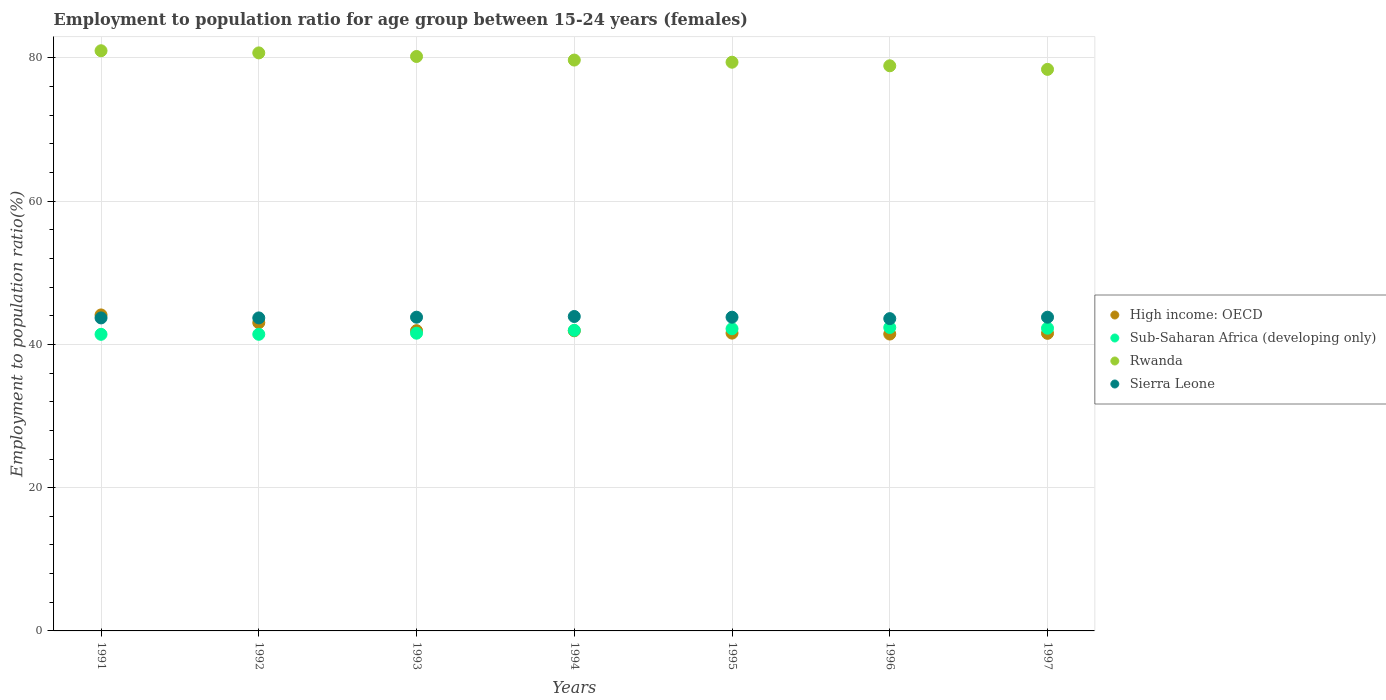Is the number of dotlines equal to the number of legend labels?
Provide a succinct answer. Yes. What is the employment to population ratio in Sub-Saharan Africa (developing only) in 1995?
Your response must be concise. 42.19. Across all years, what is the maximum employment to population ratio in Sierra Leone?
Offer a very short reply. 43.9. Across all years, what is the minimum employment to population ratio in Sierra Leone?
Your answer should be compact. 43.6. In which year was the employment to population ratio in Sub-Saharan Africa (developing only) maximum?
Your response must be concise. 1996. In which year was the employment to population ratio in Sierra Leone minimum?
Ensure brevity in your answer.  1996. What is the total employment to population ratio in High income: OECD in the graph?
Ensure brevity in your answer.  295.55. What is the difference between the employment to population ratio in High income: OECD in 1994 and that in 1996?
Offer a terse response. 0.45. What is the difference between the employment to population ratio in Sub-Saharan Africa (developing only) in 1991 and the employment to population ratio in Rwanda in 1992?
Keep it short and to the point. -39.29. What is the average employment to population ratio in Sierra Leone per year?
Ensure brevity in your answer.  43.76. In the year 1997, what is the difference between the employment to population ratio in Rwanda and employment to population ratio in Sub-Saharan Africa (developing only)?
Keep it short and to the point. 36.14. In how many years, is the employment to population ratio in Sierra Leone greater than 36 %?
Make the answer very short. 7. What is the ratio of the employment to population ratio in Sierra Leone in 1991 to that in 1995?
Your answer should be very brief. 1. Is the employment to population ratio in Sierra Leone in 1993 less than that in 1995?
Your answer should be very brief. No. Is the difference between the employment to population ratio in Rwanda in 1991 and 1997 greater than the difference between the employment to population ratio in Sub-Saharan Africa (developing only) in 1991 and 1997?
Provide a succinct answer. Yes. What is the difference between the highest and the second highest employment to population ratio in Rwanda?
Offer a terse response. 0.3. What is the difference between the highest and the lowest employment to population ratio in Sub-Saharan Africa (developing only)?
Your response must be concise. 0.95. Is the sum of the employment to population ratio in High income: OECD in 1991 and 1993 greater than the maximum employment to population ratio in Sierra Leone across all years?
Your answer should be compact. Yes. Is it the case that in every year, the sum of the employment to population ratio in Sierra Leone and employment to population ratio in High income: OECD  is greater than the employment to population ratio in Rwanda?
Your answer should be very brief. Yes. Is the employment to population ratio in Sierra Leone strictly greater than the employment to population ratio in Rwanda over the years?
Provide a succinct answer. No. Is the employment to population ratio in High income: OECD strictly less than the employment to population ratio in Sub-Saharan Africa (developing only) over the years?
Provide a short and direct response. No. Does the graph contain any zero values?
Offer a terse response. No. Does the graph contain grids?
Offer a terse response. Yes. Where does the legend appear in the graph?
Give a very brief answer. Center right. How many legend labels are there?
Offer a terse response. 4. How are the legend labels stacked?
Keep it short and to the point. Vertical. What is the title of the graph?
Offer a very short reply. Employment to population ratio for age group between 15-24 years (females). What is the label or title of the Y-axis?
Your response must be concise. Employment to population ratio(%). What is the Employment to population ratio(%) in High income: OECD in 1991?
Your answer should be compact. 44.12. What is the Employment to population ratio(%) of Sub-Saharan Africa (developing only) in 1991?
Give a very brief answer. 41.41. What is the Employment to population ratio(%) in Rwanda in 1991?
Your answer should be compact. 81. What is the Employment to population ratio(%) in Sierra Leone in 1991?
Your answer should be compact. 43.7. What is the Employment to population ratio(%) of High income: OECD in 1992?
Ensure brevity in your answer.  43.03. What is the Employment to population ratio(%) in Sub-Saharan Africa (developing only) in 1992?
Make the answer very short. 41.41. What is the Employment to population ratio(%) of Rwanda in 1992?
Your answer should be compact. 80.7. What is the Employment to population ratio(%) in Sierra Leone in 1992?
Ensure brevity in your answer.  43.7. What is the Employment to population ratio(%) of High income: OECD in 1993?
Give a very brief answer. 41.92. What is the Employment to population ratio(%) of Sub-Saharan Africa (developing only) in 1993?
Make the answer very short. 41.57. What is the Employment to population ratio(%) of Rwanda in 1993?
Offer a very short reply. 80.2. What is the Employment to population ratio(%) in Sierra Leone in 1993?
Your answer should be compact. 43.8. What is the Employment to population ratio(%) of High income: OECD in 1994?
Your answer should be very brief. 41.9. What is the Employment to population ratio(%) of Sub-Saharan Africa (developing only) in 1994?
Your answer should be very brief. 41.97. What is the Employment to population ratio(%) of Rwanda in 1994?
Keep it short and to the point. 79.7. What is the Employment to population ratio(%) of Sierra Leone in 1994?
Offer a very short reply. 43.9. What is the Employment to population ratio(%) in High income: OECD in 1995?
Provide a short and direct response. 41.58. What is the Employment to population ratio(%) of Sub-Saharan Africa (developing only) in 1995?
Offer a terse response. 42.19. What is the Employment to population ratio(%) in Rwanda in 1995?
Keep it short and to the point. 79.4. What is the Employment to population ratio(%) in Sierra Leone in 1995?
Offer a terse response. 43.8. What is the Employment to population ratio(%) of High income: OECD in 1996?
Offer a very short reply. 41.45. What is the Employment to population ratio(%) of Sub-Saharan Africa (developing only) in 1996?
Ensure brevity in your answer.  42.36. What is the Employment to population ratio(%) in Rwanda in 1996?
Make the answer very short. 78.9. What is the Employment to population ratio(%) in Sierra Leone in 1996?
Your answer should be compact. 43.6. What is the Employment to population ratio(%) in High income: OECD in 1997?
Your answer should be compact. 41.55. What is the Employment to population ratio(%) of Sub-Saharan Africa (developing only) in 1997?
Offer a terse response. 42.26. What is the Employment to population ratio(%) in Rwanda in 1997?
Your response must be concise. 78.4. What is the Employment to population ratio(%) of Sierra Leone in 1997?
Provide a short and direct response. 43.8. Across all years, what is the maximum Employment to population ratio(%) of High income: OECD?
Provide a short and direct response. 44.12. Across all years, what is the maximum Employment to population ratio(%) in Sub-Saharan Africa (developing only)?
Your response must be concise. 42.36. Across all years, what is the maximum Employment to population ratio(%) of Rwanda?
Make the answer very short. 81. Across all years, what is the maximum Employment to population ratio(%) of Sierra Leone?
Provide a short and direct response. 43.9. Across all years, what is the minimum Employment to population ratio(%) in High income: OECD?
Your answer should be very brief. 41.45. Across all years, what is the minimum Employment to population ratio(%) in Sub-Saharan Africa (developing only)?
Offer a very short reply. 41.41. Across all years, what is the minimum Employment to population ratio(%) of Rwanda?
Your answer should be compact. 78.4. Across all years, what is the minimum Employment to population ratio(%) in Sierra Leone?
Provide a short and direct response. 43.6. What is the total Employment to population ratio(%) in High income: OECD in the graph?
Ensure brevity in your answer.  295.55. What is the total Employment to population ratio(%) in Sub-Saharan Africa (developing only) in the graph?
Your response must be concise. 293.17. What is the total Employment to population ratio(%) in Rwanda in the graph?
Make the answer very short. 558.3. What is the total Employment to population ratio(%) of Sierra Leone in the graph?
Offer a terse response. 306.3. What is the difference between the Employment to population ratio(%) of High income: OECD in 1991 and that in 1992?
Offer a very short reply. 1.08. What is the difference between the Employment to population ratio(%) in Sub-Saharan Africa (developing only) in 1991 and that in 1992?
Provide a succinct answer. -0. What is the difference between the Employment to population ratio(%) of High income: OECD in 1991 and that in 1993?
Your response must be concise. 2.2. What is the difference between the Employment to population ratio(%) in Sub-Saharan Africa (developing only) in 1991 and that in 1993?
Provide a short and direct response. -0.16. What is the difference between the Employment to population ratio(%) in High income: OECD in 1991 and that in 1994?
Ensure brevity in your answer.  2.21. What is the difference between the Employment to population ratio(%) of Sub-Saharan Africa (developing only) in 1991 and that in 1994?
Your answer should be very brief. -0.56. What is the difference between the Employment to population ratio(%) of Rwanda in 1991 and that in 1994?
Your response must be concise. 1.3. What is the difference between the Employment to population ratio(%) of High income: OECD in 1991 and that in 1995?
Give a very brief answer. 2.54. What is the difference between the Employment to population ratio(%) in Sub-Saharan Africa (developing only) in 1991 and that in 1995?
Offer a terse response. -0.78. What is the difference between the Employment to population ratio(%) of Rwanda in 1991 and that in 1995?
Provide a succinct answer. 1.6. What is the difference between the Employment to population ratio(%) in High income: OECD in 1991 and that in 1996?
Your answer should be very brief. 2.67. What is the difference between the Employment to population ratio(%) of Sub-Saharan Africa (developing only) in 1991 and that in 1996?
Ensure brevity in your answer.  -0.95. What is the difference between the Employment to population ratio(%) in Rwanda in 1991 and that in 1996?
Offer a terse response. 2.1. What is the difference between the Employment to population ratio(%) of Sierra Leone in 1991 and that in 1996?
Keep it short and to the point. 0.1. What is the difference between the Employment to population ratio(%) of High income: OECD in 1991 and that in 1997?
Offer a terse response. 2.57. What is the difference between the Employment to population ratio(%) in Sub-Saharan Africa (developing only) in 1991 and that in 1997?
Your answer should be very brief. -0.85. What is the difference between the Employment to population ratio(%) of Sierra Leone in 1991 and that in 1997?
Provide a short and direct response. -0.1. What is the difference between the Employment to population ratio(%) in High income: OECD in 1992 and that in 1993?
Give a very brief answer. 1.11. What is the difference between the Employment to population ratio(%) in Sub-Saharan Africa (developing only) in 1992 and that in 1993?
Offer a terse response. -0.16. What is the difference between the Employment to population ratio(%) in Sierra Leone in 1992 and that in 1993?
Your answer should be very brief. -0.1. What is the difference between the Employment to population ratio(%) of High income: OECD in 1992 and that in 1994?
Give a very brief answer. 1.13. What is the difference between the Employment to population ratio(%) in Sub-Saharan Africa (developing only) in 1992 and that in 1994?
Your answer should be very brief. -0.56. What is the difference between the Employment to population ratio(%) of Sierra Leone in 1992 and that in 1994?
Your response must be concise. -0.2. What is the difference between the Employment to population ratio(%) in High income: OECD in 1992 and that in 1995?
Offer a very short reply. 1.45. What is the difference between the Employment to population ratio(%) in Sub-Saharan Africa (developing only) in 1992 and that in 1995?
Keep it short and to the point. -0.77. What is the difference between the Employment to population ratio(%) in Rwanda in 1992 and that in 1995?
Give a very brief answer. 1.3. What is the difference between the Employment to population ratio(%) of Sierra Leone in 1992 and that in 1995?
Provide a short and direct response. -0.1. What is the difference between the Employment to population ratio(%) of High income: OECD in 1992 and that in 1996?
Your answer should be very brief. 1.58. What is the difference between the Employment to population ratio(%) of Sub-Saharan Africa (developing only) in 1992 and that in 1996?
Offer a terse response. -0.95. What is the difference between the Employment to population ratio(%) in Rwanda in 1992 and that in 1996?
Make the answer very short. 1.8. What is the difference between the Employment to population ratio(%) of Sierra Leone in 1992 and that in 1996?
Your answer should be very brief. 0.1. What is the difference between the Employment to population ratio(%) of High income: OECD in 1992 and that in 1997?
Your answer should be very brief. 1.49. What is the difference between the Employment to population ratio(%) in Sub-Saharan Africa (developing only) in 1992 and that in 1997?
Give a very brief answer. -0.85. What is the difference between the Employment to population ratio(%) in Sierra Leone in 1992 and that in 1997?
Your response must be concise. -0.1. What is the difference between the Employment to population ratio(%) in High income: OECD in 1993 and that in 1994?
Offer a terse response. 0.02. What is the difference between the Employment to population ratio(%) of Sub-Saharan Africa (developing only) in 1993 and that in 1994?
Give a very brief answer. -0.4. What is the difference between the Employment to population ratio(%) in High income: OECD in 1993 and that in 1995?
Ensure brevity in your answer.  0.34. What is the difference between the Employment to population ratio(%) of Sub-Saharan Africa (developing only) in 1993 and that in 1995?
Provide a short and direct response. -0.62. What is the difference between the Employment to population ratio(%) of Rwanda in 1993 and that in 1995?
Make the answer very short. 0.8. What is the difference between the Employment to population ratio(%) in Sierra Leone in 1993 and that in 1995?
Offer a very short reply. 0. What is the difference between the Employment to population ratio(%) of High income: OECD in 1993 and that in 1996?
Provide a short and direct response. 0.47. What is the difference between the Employment to population ratio(%) of Sub-Saharan Africa (developing only) in 1993 and that in 1996?
Your response must be concise. -0.79. What is the difference between the Employment to population ratio(%) in Rwanda in 1993 and that in 1996?
Your answer should be very brief. 1.3. What is the difference between the Employment to population ratio(%) of Sierra Leone in 1993 and that in 1996?
Ensure brevity in your answer.  0.2. What is the difference between the Employment to population ratio(%) in High income: OECD in 1993 and that in 1997?
Make the answer very short. 0.37. What is the difference between the Employment to population ratio(%) in Sub-Saharan Africa (developing only) in 1993 and that in 1997?
Your response must be concise. -0.69. What is the difference between the Employment to population ratio(%) of Rwanda in 1993 and that in 1997?
Make the answer very short. 1.8. What is the difference between the Employment to population ratio(%) of Sierra Leone in 1993 and that in 1997?
Your answer should be compact. 0. What is the difference between the Employment to population ratio(%) of High income: OECD in 1994 and that in 1995?
Keep it short and to the point. 0.32. What is the difference between the Employment to population ratio(%) in Sub-Saharan Africa (developing only) in 1994 and that in 1995?
Give a very brief answer. -0.22. What is the difference between the Employment to population ratio(%) in Rwanda in 1994 and that in 1995?
Provide a succinct answer. 0.3. What is the difference between the Employment to population ratio(%) in Sierra Leone in 1994 and that in 1995?
Give a very brief answer. 0.1. What is the difference between the Employment to population ratio(%) of High income: OECD in 1994 and that in 1996?
Your answer should be very brief. 0.45. What is the difference between the Employment to population ratio(%) in Sub-Saharan Africa (developing only) in 1994 and that in 1996?
Your response must be concise. -0.39. What is the difference between the Employment to population ratio(%) of Rwanda in 1994 and that in 1996?
Make the answer very short. 0.8. What is the difference between the Employment to population ratio(%) of Sierra Leone in 1994 and that in 1996?
Make the answer very short. 0.3. What is the difference between the Employment to population ratio(%) of High income: OECD in 1994 and that in 1997?
Your response must be concise. 0.36. What is the difference between the Employment to population ratio(%) of Sub-Saharan Africa (developing only) in 1994 and that in 1997?
Keep it short and to the point. -0.29. What is the difference between the Employment to population ratio(%) in High income: OECD in 1995 and that in 1996?
Provide a succinct answer. 0.13. What is the difference between the Employment to population ratio(%) of Sub-Saharan Africa (developing only) in 1995 and that in 1996?
Your answer should be very brief. -0.18. What is the difference between the Employment to population ratio(%) in High income: OECD in 1995 and that in 1997?
Provide a succinct answer. 0.03. What is the difference between the Employment to population ratio(%) in Sub-Saharan Africa (developing only) in 1995 and that in 1997?
Ensure brevity in your answer.  -0.08. What is the difference between the Employment to population ratio(%) in Rwanda in 1995 and that in 1997?
Your response must be concise. 1. What is the difference between the Employment to population ratio(%) of Sierra Leone in 1995 and that in 1997?
Give a very brief answer. 0. What is the difference between the Employment to population ratio(%) of High income: OECD in 1996 and that in 1997?
Your answer should be very brief. -0.1. What is the difference between the Employment to population ratio(%) in Sub-Saharan Africa (developing only) in 1996 and that in 1997?
Provide a succinct answer. 0.1. What is the difference between the Employment to population ratio(%) in High income: OECD in 1991 and the Employment to population ratio(%) in Sub-Saharan Africa (developing only) in 1992?
Provide a succinct answer. 2.71. What is the difference between the Employment to population ratio(%) in High income: OECD in 1991 and the Employment to population ratio(%) in Rwanda in 1992?
Make the answer very short. -36.58. What is the difference between the Employment to population ratio(%) of High income: OECD in 1991 and the Employment to population ratio(%) of Sierra Leone in 1992?
Provide a short and direct response. 0.42. What is the difference between the Employment to population ratio(%) of Sub-Saharan Africa (developing only) in 1991 and the Employment to population ratio(%) of Rwanda in 1992?
Ensure brevity in your answer.  -39.29. What is the difference between the Employment to population ratio(%) of Sub-Saharan Africa (developing only) in 1991 and the Employment to population ratio(%) of Sierra Leone in 1992?
Offer a very short reply. -2.29. What is the difference between the Employment to population ratio(%) of Rwanda in 1991 and the Employment to population ratio(%) of Sierra Leone in 1992?
Your answer should be very brief. 37.3. What is the difference between the Employment to population ratio(%) in High income: OECD in 1991 and the Employment to population ratio(%) in Sub-Saharan Africa (developing only) in 1993?
Your response must be concise. 2.55. What is the difference between the Employment to population ratio(%) in High income: OECD in 1991 and the Employment to population ratio(%) in Rwanda in 1993?
Provide a short and direct response. -36.08. What is the difference between the Employment to population ratio(%) of High income: OECD in 1991 and the Employment to population ratio(%) of Sierra Leone in 1993?
Make the answer very short. 0.32. What is the difference between the Employment to population ratio(%) of Sub-Saharan Africa (developing only) in 1991 and the Employment to population ratio(%) of Rwanda in 1993?
Offer a terse response. -38.79. What is the difference between the Employment to population ratio(%) in Sub-Saharan Africa (developing only) in 1991 and the Employment to population ratio(%) in Sierra Leone in 1993?
Give a very brief answer. -2.39. What is the difference between the Employment to population ratio(%) of Rwanda in 1991 and the Employment to population ratio(%) of Sierra Leone in 1993?
Keep it short and to the point. 37.2. What is the difference between the Employment to population ratio(%) of High income: OECD in 1991 and the Employment to population ratio(%) of Sub-Saharan Africa (developing only) in 1994?
Your answer should be very brief. 2.15. What is the difference between the Employment to population ratio(%) of High income: OECD in 1991 and the Employment to population ratio(%) of Rwanda in 1994?
Your answer should be very brief. -35.58. What is the difference between the Employment to population ratio(%) in High income: OECD in 1991 and the Employment to population ratio(%) in Sierra Leone in 1994?
Make the answer very short. 0.22. What is the difference between the Employment to population ratio(%) in Sub-Saharan Africa (developing only) in 1991 and the Employment to population ratio(%) in Rwanda in 1994?
Offer a very short reply. -38.29. What is the difference between the Employment to population ratio(%) in Sub-Saharan Africa (developing only) in 1991 and the Employment to population ratio(%) in Sierra Leone in 1994?
Your response must be concise. -2.49. What is the difference between the Employment to population ratio(%) in Rwanda in 1991 and the Employment to population ratio(%) in Sierra Leone in 1994?
Offer a very short reply. 37.1. What is the difference between the Employment to population ratio(%) in High income: OECD in 1991 and the Employment to population ratio(%) in Sub-Saharan Africa (developing only) in 1995?
Make the answer very short. 1.93. What is the difference between the Employment to population ratio(%) in High income: OECD in 1991 and the Employment to population ratio(%) in Rwanda in 1995?
Your answer should be very brief. -35.28. What is the difference between the Employment to population ratio(%) of High income: OECD in 1991 and the Employment to population ratio(%) of Sierra Leone in 1995?
Your response must be concise. 0.32. What is the difference between the Employment to population ratio(%) in Sub-Saharan Africa (developing only) in 1991 and the Employment to population ratio(%) in Rwanda in 1995?
Make the answer very short. -37.99. What is the difference between the Employment to population ratio(%) in Sub-Saharan Africa (developing only) in 1991 and the Employment to population ratio(%) in Sierra Leone in 1995?
Offer a very short reply. -2.39. What is the difference between the Employment to population ratio(%) of Rwanda in 1991 and the Employment to population ratio(%) of Sierra Leone in 1995?
Offer a very short reply. 37.2. What is the difference between the Employment to population ratio(%) in High income: OECD in 1991 and the Employment to population ratio(%) in Sub-Saharan Africa (developing only) in 1996?
Ensure brevity in your answer.  1.75. What is the difference between the Employment to population ratio(%) in High income: OECD in 1991 and the Employment to population ratio(%) in Rwanda in 1996?
Your answer should be compact. -34.78. What is the difference between the Employment to population ratio(%) in High income: OECD in 1991 and the Employment to population ratio(%) in Sierra Leone in 1996?
Keep it short and to the point. 0.52. What is the difference between the Employment to population ratio(%) in Sub-Saharan Africa (developing only) in 1991 and the Employment to population ratio(%) in Rwanda in 1996?
Your response must be concise. -37.49. What is the difference between the Employment to population ratio(%) in Sub-Saharan Africa (developing only) in 1991 and the Employment to population ratio(%) in Sierra Leone in 1996?
Keep it short and to the point. -2.19. What is the difference between the Employment to population ratio(%) of Rwanda in 1991 and the Employment to population ratio(%) of Sierra Leone in 1996?
Give a very brief answer. 37.4. What is the difference between the Employment to population ratio(%) of High income: OECD in 1991 and the Employment to population ratio(%) of Sub-Saharan Africa (developing only) in 1997?
Your response must be concise. 1.85. What is the difference between the Employment to population ratio(%) of High income: OECD in 1991 and the Employment to population ratio(%) of Rwanda in 1997?
Provide a short and direct response. -34.28. What is the difference between the Employment to population ratio(%) in High income: OECD in 1991 and the Employment to population ratio(%) in Sierra Leone in 1997?
Your answer should be very brief. 0.32. What is the difference between the Employment to population ratio(%) of Sub-Saharan Africa (developing only) in 1991 and the Employment to population ratio(%) of Rwanda in 1997?
Your answer should be very brief. -36.99. What is the difference between the Employment to population ratio(%) in Sub-Saharan Africa (developing only) in 1991 and the Employment to population ratio(%) in Sierra Leone in 1997?
Keep it short and to the point. -2.39. What is the difference between the Employment to population ratio(%) in Rwanda in 1991 and the Employment to population ratio(%) in Sierra Leone in 1997?
Your response must be concise. 37.2. What is the difference between the Employment to population ratio(%) of High income: OECD in 1992 and the Employment to population ratio(%) of Sub-Saharan Africa (developing only) in 1993?
Make the answer very short. 1.47. What is the difference between the Employment to population ratio(%) of High income: OECD in 1992 and the Employment to population ratio(%) of Rwanda in 1993?
Provide a short and direct response. -37.17. What is the difference between the Employment to population ratio(%) in High income: OECD in 1992 and the Employment to population ratio(%) in Sierra Leone in 1993?
Your answer should be compact. -0.77. What is the difference between the Employment to population ratio(%) of Sub-Saharan Africa (developing only) in 1992 and the Employment to population ratio(%) of Rwanda in 1993?
Provide a short and direct response. -38.79. What is the difference between the Employment to population ratio(%) in Sub-Saharan Africa (developing only) in 1992 and the Employment to population ratio(%) in Sierra Leone in 1993?
Give a very brief answer. -2.39. What is the difference between the Employment to population ratio(%) in Rwanda in 1992 and the Employment to population ratio(%) in Sierra Leone in 1993?
Your answer should be very brief. 36.9. What is the difference between the Employment to population ratio(%) in High income: OECD in 1992 and the Employment to population ratio(%) in Sub-Saharan Africa (developing only) in 1994?
Your answer should be compact. 1.06. What is the difference between the Employment to population ratio(%) in High income: OECD in 1992 and the Employment to population ratio(%) in Rwanda in 1994?
Keep it short and to the point. -36.67. What is the difference between the Employment to population ratio(%) of High income: OECD in 1992 and the Employment to population ratio(%) of Sierra Leone in 1994?
Provide a succinct answer. -0.87. What is the difference between the Employment to population ratio(%) in Sub-Saharan Africa (developing only) in 1992 and the Employment to population ratio(%) in Rwanda in 1994?
Keep it short and to the point. -38.29. What is the difference between the Employment to population ratio(%) in Sub-Saharan Africa (developing only) in 1992 and the Employment to population ratio(%) in Sierra Leone in 1994?
Give a very brief answer. -2.49. What is the difference between the Employment to population ratio(%) in Rwanda in 1992 and the Employment to population ratio(%) in Sierra Leone in 1994?
Offer a very short reply. 36.8. What is the difference between the Employment to population ratio(%) in High income: OECD in 1992 and the Employment to population ratio(%) in Sub-Saharan Africa (developing only) in 1995?
Provide a succinct answer. 0.85. What is the difference between the Employment to population ratio(%) of High income: OECD in 1992 and the Employment to population ratio(%) of Rwanda in 1995?
Provide a succinct answer. -36.37. What is the difference between the Employment to population ratio(%) in High income: OECD in 1992 and the Employment to population ratio(%) in Sierra Leone in 1995?
Your answer should be compact. -0.77. What is the difference between the Employment to population ratio(%) in Sub-Saharan Africa (developing only) in 1992 and the Employment to population ratio(%) in Rwanda in 1995?
Provide a succinct answer. -37.99. What is the difference between the Employment to population ratio(%) of Sub-Saharan Africa (developing only) in 1992 and the Employment to population ratio(%) of Sierra Leone in 1995?
Your answer should be compact. -2.39. What is the difference between the Employment to population ratio(%) in Rwanda in 1992 and the Employment to population ratio(%) in Sierra Leone in 1995?
Your answer should be compact. 36.9. What is the difference between the Employment to population ratio(%) of High income: OECD in 1992 and the Employment to population ratio(%) of Sub-Saharan Africa (developing only) in 1996?
Offer a very short reply. 0.67. What is the difference between the Employment to population ratio(%) of High income: OECD in 1992 and the Employment to population ratio(%) of Rwanda in 1996?
Offer a terse response. -35.87. What is the difference between the Employment to population ratio(%) of High income: OECD in 1992 and the Employment to population ratio(%) of Sierra Leone in 1996?
Ensure brevity in your answer.  -0.57. What is the difference between the Employment to population ratio(%) in Sub-Saharan Africa (developing only) in 1992 and the Employment to population ratio(%) in Rwanda in 1996?
Keep it short and to the point. -37.49. What is the difference between the Employment to population ratio(%) of Sub-Saharan Africa (developing only) in 1992 and the Employment to population ratio(%) of Sierra Leone in 1996?
Make the answer very short. -2.19. What is the difference between the Employment to population ratio(%) of Rwanda in 1992 and the Employment to population ratio(%) of Sierra Leone in 1996?
Provide a succinct answer. 37.1. What is the difference between the Employment to population ratio(%) in High income: OECD in 1992 and the Employment to population ratio(%) in Sub-Saharan Africa (developing only) in 1997?
Provide a short and direct response. 0.77. What is the difference between the Employment to population ratio(%) of High income: OECD in 1992 and the Employment to population ratio(%) of Rwanda in 1997?
Offer a terse response. -35.37. What is the difference between the Employment to population ratio(%) of High income: OECD in 1992 and the Employment to population ratio(%) of Sierra Leone in 1997?
Your answer should be very brief. -0.77. What is the difference between the Employment to population ratio(%) in Sub-Saharan Africa (developing only) in 1992 and the Employment to population ratio(%) in Rwanda in 1997?
Provide a succinct answer. -36.99. What is the difference between the Employment to population ratio(%) in Sub-Saharan Africa (developing only) in 1992 and the Employment to population ratio(%) in Sierra Leone in 1997?
Make the answer very short. -2.39. What is the difference between the Employment to population ratio(%) in Rwanda in 1992 and the Employment to population ratio(%) in Sierra Leone in 1997?
Your answer should be very brief. 36.9. What is the difference between the Employment to population ratio(%) in High income: OECD in 1993 and the Employment to population ratio(%) in Sub-Saharan Africa (developing only) in 1994?
Keep it short and to the point. -0.05. What is the difference between the Employment to population ratio(%) in High income: OECD in 1993 and the Employment to population ratio(%) in Rwanda in 1994?
Offer a terse response. -37.78. What is the difference between the Employment to population ratio(%) in High income: OECD in 1993 and the Employment to population ratio(%) in Sierra Leone in 1994?
Your response must be concise. -1.98. What is the difference between the Employment to population ratio(%) in Sub-Saharan Africa (developing only) in 1993 and the Employment to population ratio(%) in Rwanda in 1994?
Make the answer very short. -38.13. What is the difference between the Employment to population ratio(%) of Sub-Saharan Africa (developing only) in 1993 and the Employment to population ratio(%) of Sierra Leone in 1994?
Your response must be concise. -2.33. What is the difference between the Employment to population ratio(%) of Rwanda in 1993 and the Employment to population ratio(%) of Sierra Leone in 1994?
Make the answer very short. 36.3. What is the difference between the Employment to population ratio(%) of High income: OECD in 1993 and the Employment to population ratio(%) of Sub-Saharan Africa (developing only) in 1995?
Offer a terse response. -0.26. What is the difference between the Employment to population ratio(%) in High income: OECD in 1993 and the Employment to population ratio(%) in Rwanda in 1995?
Give a very brief answer. -37.48. What is the difference between the Employment to population ratio(%) of High income: OECD in 1993 and the Employment to population ratio(%) of Sierra Leone in 1995?
Keep it short and to the point. -1.88. What is the difference between the Employment to population ratio(%) in Sub-Saharan Africa (developing only) in 1993 and the Employment to population ratio(%) in Rwanda in 1995?
Offer a terse response. -37.83. What is the difference between the Employment to population ratio(%) of Sub-Saharan Africa (developing only) in 1993 and the Employment to population ratio(%) of Sierra Leone in 1995?
Give a very brief answer. -2.23. What is the difference between the Employment to population ratio(%) in Rwanda in 1993 and the Employment to population ratio(%) in Sierra Leone in 1995?
Your response must be concise. 36.4. What is the difference between the Employment to population ratio(%) in High income: OECD in 1993 and the Employment to population ratio(%) in Sub-Saharan Africa (developing only) in 1996?
Provide a short and direct response. -0.44. What is the difference between the Employment to population ratio(%) of High income: OECD in 1993 and the Employment to population ratio(%) of Rwanda in 1996?
Your response must be concise. -36.98. What is the difference between the Employment to population ratio(%) of High income: OECD in 1993 and the Employment to population ratio(%) of Sierra Leone in 1996?
Your response must be concise. -1.68. What is the difference between the Employment to population ratio(%) of Sub-Saharan Africa (developing only) in 1993 and the Employment to population ratio(%) of Rwanda in 1996?
Give a very brief answer. -37.33. What is the difference between the Employment to population ratio(%) of Sub-Saharan Africa (developing only) in 1993 and the Employment to population ratio(%) of Sierra Leone in 1996?
Make the answer very short. -2.03. What is the difference between the Employment to population ratio(%) of Rwanda in 1993 and the Employment to population ratio(%) of Sierra Leone in 1996?
Keep it short and to the point. 36.6. What is the difference between the Employment to population ratio(%) of High income: OECD in 1993 and the Employment to population ratio(%) of Sub-Saharan Africa (developing only) in 1997?
Give a very brief answer. -0.34. What is the difference between the Employment to population ratio(%) in High income: OECD in 1993 and the Employment to population ratio(%) in Rwanda in 1997?
Offer a very short reply. -36.48. What is the difference between the Employment to population ratio(%) in High income: OECD in 1993 and the Employment to population ratio(%) in Sierra Leone in 1997?
Ensure brevity in your answer.  -1.88. What is the difference between the Employment to population ratio(%) in Sub-Saharan Africa (developing only) in 1993 and the Employment to population ratio(%) in Rwanda in 1997?
Ensure brevity in your answer.  -36.83. What is the difference between the Employment to population ratio(%) of Sub-Saharan Africa (developing only) in 1993 and the Employment to population ratio(%) of Sierra Leone in 1997?
Provide a succinct answer. -2.23. What is the difference between the Employment to population ratio(%) in Rwanda in 1993 and the Employment to population ratio(%) in Sierra Leone in 1997?
Provide a succinct answer. 36.4. What is the difference between the Employment to population ratio(%) of High income: OECD in 1994 and the Employment to population ratio(%) of Sub-Saharan Africa (developing only) in 1995?
Your response must be concise. -0.28. What is the difference between the Employment to population ratio(%) in High income: OECD in 1994 and the Employment to population ratio(%) in Rwanda in 1995?
Your answer should be very brief. -37.5. What is the difference between the Employment to population ratio(%) of High income: OECD in 1994 and the Employment to population ratio(%) of Sierra Leone in 1995?
Provide a short and direct response. -1.9. What is the difference between the Employment to population ratio(%) in Sub-Saharan Africa (developing only) in 1994 and the Employment to population ratio(%) in Rwanda in 1995?
Your answer should be very brief. -37.43. What is the difference between the Employment to population ratio(%) in Sub-Saharan Africa (developing only) in 1994 and the Employment to population ratio(%) in Sierra Leone in 1995?
Provide a short and direct response. -1.83. What is the difference between the Employment to population ratio(%) of Rwanda in 1994 and the Employment to population ratio(%) of Sierra Leone in 1995?
Your response must be concise. 35.9. What is the difference between the Employment to population ratio(%) in High income: OECD in 1994 and the Employment to population ratio(%) in Sub-Saharan Africa (developing only) in 1996?
Your answer should be very brief. -0.46. What is the difference between the Employment to population ratio(%) of High income: OECD in 1994 and the Employment to population ratio(%) of Rwanda in 1996?
Your answer should be very brief. -37. What is the difference between the Employment to population ratio(%) of High income: OECD in 1994 and the Employment to population ratio(%) of Sierra Leone in 1996?
Provide a short and direct response. -1.7. What is the difference between the Employment to population ratio(%) in Sub-Saharan Africa (developing only) in 1994 and the Employment to population ratio(%) in Rwanda in 1996?
Your answer should be compact. -36.93. What is the difference between the Employment to population ratio(%) in Sub-Saharan Africa (developing only) in 1994 and the Employment to population ratio(%) in Sierra Leone in 1996?
Make the answer very short. -1.63. What is the difference between the Employment to population ratio(%) in Rwanda in 1994 and the Employment to population ratio(%) in Sierra Leone in 1996?
Your answer should be compact. 36.1. What is the difference between the Employment to population ratio(%) in High income: OECD in 1994 and the Employment to population ratio(%) in Sub-Saharan Africa (developing only) in 1997?
Provide a short and direct response. -0.36. What is the difference between the Employment to population ratio(%) in High income: OECD in 1994 and the Employment to population ratio(%) in Rwanda in 1997?
Your response must be concise. -36.5. What is the difference between the Employment to population ratio(%) of High income: OECD in 1994 and the Employment to population ratio(%) of Sierra Leone in 1997?
Make the answer very short. -1.9. What is the difference between the Employment to population ratio(%) of Sub-Saharan Africa (developing only) in 1994 and the Employment to population ratio(%) of Rwanda in 1997?
Offer a very short reply. -36.43. What is the difference between the Employment to population ratio(%) in Sub-Saharan Africa (developing only) in 1994 and the Employment to population ratio(%) in Sierra Leone in 1997?
Your response must be concise. -1.83. What is the difference between the Employment to population ratio(%) of Rwanda in 1994 and the Employment to population ratio(%) of Sierra Leone in 1997?
Provide a succinct answer. 35.9. What is the difference between the Employment to population ratio(%) in High income: OECD in 1995 and the Employment to population ratio(%) in Sub-Saharan Africa (developing only) in 1996?
Offer a terse response. -0.78. What is the difference between the Employment to population ratio(%) of High income: OECD in 1995 and the Employment to population ratio(%) of Rwanda in 1996?
Make the answer very short. -37.32. What is the difference between the Employment to population ratio(%) in High income: OECD in 1995 and the Employment to population ratio(%) in Sierra Leone in 1996?
Your answer should be compact. -2.02. What is the difference between the Employment to population ratio(%) of Sub-Saharan Africa (developing only) in 1995 and the Employment to population ratio(%) of Rwanda in 1996?
Keep it short and to the point. -36.71. What is the difference between the Employment to population ratio(%) in Sub-Saharan Africa (developing only) in 1995 and the Employment to population ratio(%) in Sierra Leone in 1996?
Provide a short and direct response. -1.41. What is the difference between the Employment to population ratio(%) of Rwanda in 1995 and the Employment to population ratio(%) of Sierra Leone in 1996?
Offer a very short reply. 35.8. What is the difference between the Employment to population ratio(%) in High income: OECD in 1995 and the Employment to population ratio(%) in Sub-Saharan Africa (developing only) in 1997?
Your answer should be very brief. -0.68. What is the difference between the Employment to population ratio(%) in High income: OECD in 1995 and the Employment to population ratio(%) in Rwanda in 1997?
Ensure brevity in your answer.  -36.82. What is the difference between the Employment to population ratio(%) of High income: OECD in 1995 and the Employment to population ratio(%) of Sierra Leone in 1997?
Give a very brief answer. -2.22. What is the difference between the Employment to population ratio(%) in Sub-Saharan Africa (developing only) in 1995 and the Employment to population ratio(%) in Rwanda in 1997?
Keep it short and to the point. -36.21. What is the difference between the Employment to population ratio(%) of Sub-Saharan Africa (developing only) in 1995 and the Employment to population ratio(%) of Sierra Leone in 1997?
Make the answer very short. -1.61. What is the difference between the Employment to population ratio(%) in Rwanda in 1995 and the Employment to population ratio(%) in Sierra Leone in 1997?
Provide a succinct answer. 35.6. What is the difference between the Employment to population ratio(%) of High income: OECD in 1996 and the Employment to population ratio(%) of Sub-Saharan Africa (developing only) in 1997?
Keep it short and to the point. -0.81. What is the difference between the Employment to population ratio(%) in High income: OECD in 1996 and the Employment to population ratio(%) in Rwanda in 1997?
Ensure brevity in your answer.  -36.95. What is the difference between the Employment to population ratio(%) of High income: OECD in 1996 and the Employment to population ratio(%) of Sierra Leone in 1997?
Offer a very short reply. -2.35. What is the difference between the Employment to population ratio(%) in Sub-Saharan Africa (developing only) in 1996 and the Employment to population ratio(%) in Rwanda in 1997?
Give a very brief answer. -36.04. What is the difference between the Employment to population ratio(%) of Sub-Saharan Africa (developing only) in 1996 and the Employment to population ratio(%) of Sierra Leone in 1997?
Provide a short and direct response. -1.44. What is the difference between the Employment to population ratio(%) in Rwanda in 1996 and the Employment to population ratio(%) in Sierra Leone in 1997?
Offer a very short reply. 35.1. What is the average Employment to population ratio(%) of High income: OECD per year?
Provide a succinct answer. 42.22. What is the average Employment to population ratio(%) of Sub-Saharan Africa (developing only) per year?
Your response must be concise. 41.88. What is the average Employment to population ratio(%) in Rwanda per year?
Offer a terse response. 79.76. What is the average Employment to population ratio(%) of Sierra Leone per year?
Your response must be concise. 43.76. In the year 1991, what is the difference between the Employment to population ratio(%) of High income: OECD and Employment to population ratio(%) of Sub-Saharan Africa (developing only)?
Ensure brevity in your answer.  2.71. In the year 1991, what is the difference between the Employment to population ratio(%) of High income: OECD and Employment to population ratio(%) of Rwanda?
Offer a terse response. -36.88. In the year 1991, what is the difference between the Employment to population ratio(%) of High income: OECD and Employment to population ratio(%) of Sierra Leone?
Offer a terse response. 0.42. In the year 1991, what is the difference between the Employment to population ratio(%) in Sub-Saharan Africa (developing only) and Employment to population ratio(%) in Rwanda?
Make the answer very short. -39.59. In the year 1991, what is the difference between the Employment to population ratio(%) of Sub-Saharan Africa (developing only) and Employment to population ratio(%) of Sierra Leone?
Keep it short and to the point. -2.29. In the year 1991, what is the difference between the Employment to population ratio(%) of Rwanda and Employment to population ratio(%) of Sierra Leone?
Ensure brevity in your answer.  37.3. In the year 1992, what is the difference between the Employment to population ratio(%) of High income: OECD and Employment to population ratio(%) of Sub-Saharan Africa (developing only)?
Provide a short and direct response. 1.62. In the year 1992, what is the difference between the Employment to population ratio(%) in High income: OECD and Employment to population ratio(%) in Rwanda?
Your answer should be compact. -37.67. In the year 1992, what is the difference between the Employment to population ratio(%) in High income: OECD and Employment to population ratio(%) in Sierra Leone?
Ensure brevity in your answer.  -0.67. In the year 1992, what is the difference between the Employment to population ratio(%) of Sub-Saharan Africa (developing only) and Employment to population ratio(%) of Rwanda?
Keep it short and to the point. -39.29. In the year 1992, what is the difference between the Employment to population ratio(%) of Sub-Saharan Africa (developing only) and Employment to population ratio(%) of Sierra Leone?
Offer a terse response. -2.29. In the year 1993, what is the difference between the Employment to population ratio(%) of High income: OECD and Employment to population ratio(%) of Sub-Saharan Africa (developing only)?
Offer a very short reply. 0.35. In the year 1993, what is the difference between the Employment to population ratio(%) in High income: OECD and Employment to population ratio(%) in Rwanda?
Make the answer very short. -38.28. In the year 1993, what is the difference between the Employment to population ratio(%) of High income: OECD and Employment to population ratio(%) of Sierra Leone?
Your answer should be very brief. -1.88. In the year 1993, what is the difference between the Employment to population ratio(%) of Sub-Saharan Africa (developing only) and Employment to population ratio(%) of Rwanda?
Offer a terse response. -38.63. In the year 1993, what is the difference between the Employment to population ratio(%) of Sub-Saharan Africa (developing only) and Employment to population ratio(%) of Sierra Leone?
Provide a succinct answer. -2.23. In the year 1993, what is the difference between the Employment to population ratio(%) of Rwanda and Employment to population ratio(%) of Sierra Leone?
Provide a succinct answer. 36.4. In the year 1994, what is the difference between the Employment to population ratio(%) in High income: OECD and Employment to population ratio(%) in Sub-Saharan Africa (developing only)?
Provide a short and direct response. -0.07. In the year 1994, what is the difference between the Employment to population ratio(%) in High income: OECD and Employment to population ratio(%) in Rwanda?
Make the answer very short. -37.8. In the year 1994, what is the difference between the Employment to population ratio(%) of High income: OECD and Employment to population ratio(%) of Sierra Leone?
Your answer should be compact. -2. In the year 1994, what is the difference between the Employment to population ratio(%) in Sub-Saharan Africa (developing only) and Employment to population ratio(%) in Rwanda?
Make the answer very short. -37.73. In the year 1994, what is the difference between the Employment to population ratio(%) of Sub-Saharan Africa (developing only) and Employment to population ratio(%) of Sierra Leone?
Keep it short and to the point. -1.93. In the year 1994, what is the difference between the Employment to population ratio(%) in Rwanda and Employment to population ratio(%) in Sierra Leone?
Provide a short and direct response. 35.8. In the year 1995, what is the difference between the Employment to population ratio(%) of High income: OECD and Employment to population ratio(%) of Sub-Saharan Africa (developing only)?
Keep it short and to the point. -0.61. In the year 1995, what is the difference between the Employment to population ratio(%) of High income: OECD and Employment to population ratio(%) of Rwanda?
Offer a terse response. -37.82. In the year 1995, what is the difference between the Employment to population ratio(%) in High income: OECD and Employment to population ratio(%) in Sierra Leone?
Your response must be concise. -2.22. In the year 1995, what is the difference between the Employment to population ratio(%) of Sub-Saharan Africa (developing only) and Employment to population ratio(%) of Rwanda?
Ensure brevity in your answer.  -37.21. In the year 1995, what is the difference between the Employment to population ratio(%) in Sub-Saharan Africa (developing only) and Employment to population ratio(%) in Sierra Leone?
Your answer should be very brief. -1.61. In the year 1995, what is the difference between the Employment to population ratio(%) of Rwanda and Employment to population ratio(%) of Sierra Leone?
Offer a terse response. 35.6. In the year 1996, what is the difference between the Employment to population ratio(%) of High income: OECD and Employment to population ratio(%) of Sub-Saharan Africa (developing only)?
Offer a terse response. -0.91. In the year 1996, what is the difference between the Employment to population ratio(%) of High income: OECD and Employment to population ratio(%) of Rwanda?
Your answer should be compact. -37.45. In the year 1996, what is the difference between the Employment to population ratio(%) in High income: OECD and Employment to population ratio(%) in Sierra Leone?
Ensure brevity in your answer.  -2.15. In the year 1996, what is the difference between the Employment to population ratio(%) in Sub-Saharan Africa (developing only) and Employment to population ratio(%) in Rwanda?
Your answer should be very brief. -36.54. In the year 1996, what is the difference between the Employment to population ratio(%) in Sub-Saharan Africa (developing only) and Employment to population ratio(%) in Sierra Leone?
Your response must be concise. -1.24. In the year 1996, what is the difference between the Employment to population ratio(%) of Rwanda and Employment to population ratio(%) of Sierra Leone?
Keep it short and to the point. 35.3. In the year 1997, what is the difference between the Employment to population ratio(%) in High income: OECD and Employment to population ratio(%) in Sub-Saharan Africa (developing only)?
Keep it short and to the point. -0.71. In the year 1997, what is the difference between the Employment to population ratio(%) in High income: OECD and Employment to population ratio(%) in Rwanda?
Your answer should be compact. -36.85. In the year 1997, what is the difference between the Employment to population ratio(%) in High income: OECD and Employment to population ratio(%) in Sierra Leone?
Offer a very short reply. -2.25. In the year 1997, what is the difference between the Employment to population ratio(%) of Sub-Saharan Africa (developing only) and Employment to population ratio(%) of Rwanda?
Your answer should be compact. -36.14. In the year 1997, what is the difference between the Employment to population ratio(%) of Sub-Saharan Africa (developing only) and Employment to population ratio(%) of Sierra Leone?
Ensure brevity in your answer.  -1.54. In the year 1997, what is the difference between the Employment to population ratio(%) in Rwanda and Employment to population ratio(%) in Sierra Leone?
Your answer should be very brief. 34.6. What is the ratio of the Employment to population ratio(%) in High income: OECD in 1991 to that in 1992?
Offer a terse response. 1.03. What is the ratio of the Employment to population ratio(%) of Sub-Saharan Africa (developing only) in 1991 to that in 1992?
Your answer should be very brief. 1. What is the ratio of the Employment to population ratio(%) of High income: OECD in 1991 to that in 1993?
Offer a very short reply. 1.05. What is the ratio of the Employment to population ratio(%) of Rwanda in 1991 to that in 1993?
Provide a succinct answer. 1.01. What is the ratio of the Employment to population ratio(%) of Sierra Leone in 1991 to that in 1993?
Offer a terse response. 1. What is the ratio of the Employment to population ratio(%) in High income: OECD in 1991 to that in 1994?
Make the answer very short. 1.05. What is the ratio of the Employment to population ratio(%) of Sub-Saharan Africa (developing only) in 1991 to that in 1994?
Provide a short and direct response. 0.99. What is the ratio of the Employment to population ratio(%) of Rwanda in 1991 to that in 1994?
Give a very brief answer. 1.02. What is the ratio of the Employment to population ratio(%) of Sierra Leone in 1991 to that in 1994?
Make the answer very short. 1. What is the ratio of the Employment to population ratio(%) in High income: OECD in 1991 to that in 1995?
Your response must be concise. 1.06. What is the ratio of the Employment to population ratio(%) of Sub-Saharan Africa (developing only) in 1991 to that in 1995?
Your answer should be very brief. 0.98. What is the ratio of the Employment to population ratio(%) of Rwanda in 1991 to that in 1995?
Your answer should be very brief. 1.02. What is the ratio of the Employment to population ratio(%) in Sierra Leone in 1991 to that in 1995?
Offer a terse response. 1. What is the ratio of the Employment to population ratio(%) of High income: OECD in 1991 to that in 1996?
Your answer should be compact. 1.06. What is the ratio of the Employment to population ratio(%) in Sub-Saharan Africa (developing only) in 1991 to that in 1996?
Provide a short and direct response. 0.98. What is the ratio of the Employment to population ratio(%) of Rwanda in 1991 to that in 1996?
Offer a terse response. 1.03. What is the ratio of the Employment to population ratio(%) of Sierra Leone in 1991 to that in 1996?
Provide a succinct answer. 1. What is the ratio of the Employment to population ratio(%) in High income: OECD in 1991 to that in 1997?
Give a very brief answer. 1.06. What is the ratio of the Employment to population ratio(%) of Sub-Saharan Africa (developing only) in 1991 to that in 1997?
Give a very brief answer. 0.98. What is the ratio of the Employment to population ratio(%) of Rwanda in 1991 to that in 1997?
Offer a terse response. 1.03. What is the ratio of the Employment to population ratio(%) of High income: OECD in 1992 to that in 1993?
Your answer should be very brief. 1.03. What is the ratio of the Employment to population ratio(%) of Sub-Saharan Africa (developing only) in 1992 to that in 1993?
Keep it short and to the point. 1. What is the ratio of the Employment to population ratio(%) in Rwanda in 1992 to that in 1993?
Make the answer very short. 1.01. What is the ratio of the Employment to population ratio(%) of Sierra Leone in 1992 to that in 1993?
Offer a very short reply. 1. What is the ratio of the Employment to population ratio(%) in High income: OECD in 1992 to that in 1994?
Ensure brevity in your answer.  1.03. What is the ratio of the Employment to population ratio(%) in Sub-Saharan Africa (developing only) in 1992 to that in 1994?
Offer a terse response. 0.99. What is the ratio of the Employment to population ratio(%) of Rwanda in 1992 to that in 1994?
Your response must be concise. 1.01. What is the ratio of the Employment to population ratio(%) in High income: OECD in 1992 to that in 1995?
Provide a short and direct response. 1.03. What is the ratio of the Employment to population ratio(%) of Sub-Saharan Africa (developing only) in 1992 to that in 1995?
Your answer should be very brief. 0.98. What is the ratio of the Employment to population ratio(%) of Rwanda in 1992 to that in 1995?
Offer a very short reply. 1.02. What is the ratio of the Employment to population ratio(%) of High income: OECD in 1992 to that in 1996?
Your answer should be compact. 1.04. What is the ratio of the Employment to population ratio(%) of Sub-Saharan Africa (developing only) in 1992 to that in 1996?
Make the answer very short. 0.98. What is the ratio of the Employment to population ratio(%) in Rwanda in 1992 to that in 1996?
Ensure brevity in your answer.  1.02. What is the ratio of the Employment to population ratio(%) of Sierra Leone in 1992 to that in 1996?
Provide a succinct answer. 1. What is the ratio of the Employment to population ratio(%) of High income: OECD in 1992 to that in 1997?
Ensure brevity in your answer.  1.04. What is the ratio of the Employment to population ratio(%) in Sub-Saharan Africa (developing only) in 1992 to that in 1997?
Ensure brevity in your answer.  0.98. What is the ratio of the Employment to population ratio(%) in Rwanda in 1992 to that in 1997?
Keep it short and to the point. 1.03. What is the ratio of the Employment to population ratio(%) of Sierra Leone in 1992 to that in 1997?
Ensure brevity in your answer.  1. What is the ratio of the Employment to population ratio(%) in High income: OECD in 1993 to that in 1995?
Provide a short and direct response. 1.01. What is the ratio of the Employment to population ratio(%) of High income: OECD in 1993 to that in 1996?
Your response must be concise. 1.01. What is the ratio of the Employment to population ratio(%) in Sub-Saharan Africa (developing only) in 1993 to that in 1996?
Provide a short and direct response. 0.98. What is the ratio of the Employment to population ratio(%) in Rwanda in 1993 to that in 1996?
Keep it short and to the point. 1.02. What is the ratio of the Employment to population ratio(%) of Sierra Leone in 1993 to that in 1996?
Keep it short and to the point. 1. What is the ratio of the Employment to population ratio(%) in High income: OECD in 1993 to that in 1997?
Your response must be concise. 1.01. What is the ratio of the Employment to population ratio(%) in Sub-Saharan Africa (developing only) in 1993 to that in 1997?
Your response must be concise. 0.98. What is the ratio of the Employment to population ratio(%) in Rwanda in 1993 to that in 1997?
Your response must be concise. 1.02. What is the ratio of the Employment to population ratio(%) in Sierra Leone in 1993 to that in 1997?
Offer a terse response. 1. What is the ratio of the Employment to population ratio(%) of High income: OECD in 1994 to that in 1995?
Your response must be concise. 1.01. What is the ratio of the Employment to population ratio(%) of Sub-Saharan Africa (developing only) in 1994 to that in 1995?
Keep it short and to the point. 0.99. What is the ratio of the Employment to population ratio(%) of Rwanda in 1994 to that in 1995?
Ensure brevity in your answer.  1. What is the ratio of the Employment to population ratio(%) of Sierra Leone in 1994 to that in 1995?
Offer a terse response. 1. What is the ratio of the Employment to population ratio(%) of High income: OECD in 1994 to that in 1996?
Give a very brief answer. 1.01. What is the ratio of the Employment to population ratio(%) of Rwanda in 1994 to that in 1996?
Make the answer very short. 1.01. What is the ratio of the Employment to population ratio(%) of Sierra Leone in 1994 to that in 1996?
Offer a very short reply. 1.01. What is the ratio of the Employment to population ratio(%) of High income: OECD in 1994 to that in 1997?
Offer a terse response. 1.01. What is the ratio of the Employment to population ratio(%) of Rwanda in 1994 to that in 1997?
Keep it short and to the point. 1.02. What is the ratio of the Employment to population ratio(%) in High income: OECD in 1995 to that in 1997?
Your response must be concise. 1. What is the ratio of the Employment to population ratio(%) of Rwanda in 1995 to that in 1997?
Keep it short and to the point. 1.01. What is the ratio of the Employment to population ratio(%) in Sierra Leone in 1995 to that in 1997?
Ensure brevity in your answer.  1. What is the ratio of the Employment to population ratio(%) of High income: OECD in 1996 to that in 1997?
Make the answer very short. 1. What is the ratio of the Employment to population ratio(%) in Rwanda in 1996 to that in 1997?
Offer a terse response. 1.01. What is the difference between the highest and the second highest Employment to population ratio(%) of High income: OECD?
Your answer should be very brief. 1.08. What is the difference between the highest and the second highest Employment to population ratio(%) in Sub-Saharan Africa (developing only)?
Your answer should be very brief. 0.1. What is the difference between the highest and the second highest Employment to population ratio(%) of Sierra Leone?
Your answer should be compact. 0.1. What is the difference between the highest and the lowest Employment to population ratio(%) of High income: OECD?
Your answer should be very brief. 2.67. What is the difference between the highest and the lowest Employment to population ratio(%) in Sub-Saharan Africa (developing only)?
Keep it short and to the point. 0.95. What is the difference between the highest and the lowest Employment to population ratio(%) in Rwanda?
Give a very brief answer. 2.6. What is the difference between the highest and the lowest Employment to population ratio(%) of Sierra Leone?
Ensure brevity in your answer.  0.3. 